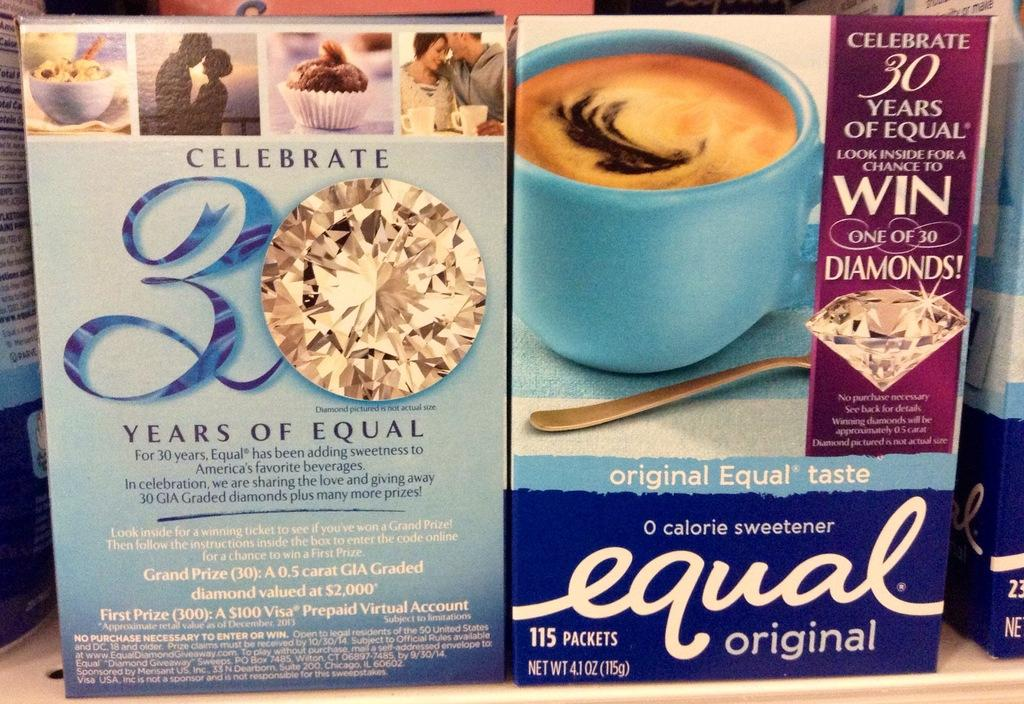<image>
Describe the image concisely. Two boxes of Equal packets celebrating 30 years of Equal. 